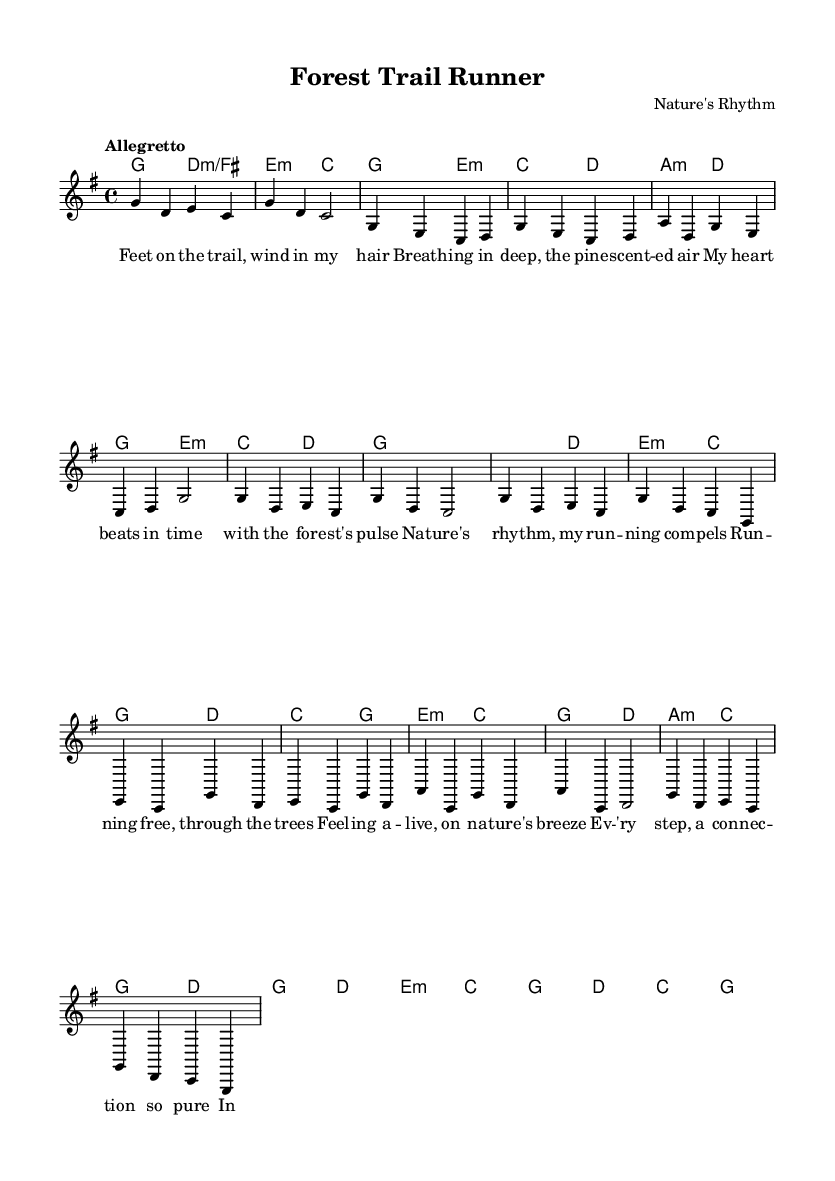What is the key signature of this music? The key signature is G major, which contains one sharp (F#). It can be identified from the key signature indication at the beginning of the score.
Answer: G major What is the time signature of this music? The time signature is 4/4, which indicates four beats per measure and is shown at the beginning of the score.
Answer: 4/4 What is the tempo marking of the piece? The tempo marking is "Allegretto," indicating a moderately fast tempo. It is specified at the beginning of the score.
Answer: Allegretto How many measures are in the chorus section? The chorus consists of 4 measures, which is determined by counting the bars marked in that section of the score.
Answer: 4 Which harmonic chord is used in the first measure? The first measure uses the G major chord, as indicated in the harmonies section at the beginning of the score.
Answer: G major What is the lyric for the first line of the verse? The first line of the verse is "Feet on the trail, wind in my hair," which can be located in the lyrics section aligned with the melody.
Answer: Feet on the trail, wind in my hair How does the music convey the theme of connecting with nature? The music conveys the theme through its lyrical content and upbeat tempo, promoting feelings of freedom and connection to the environment, as evidenced by the evocative verses and chorus.
Answer: Freedom and connection to nature 